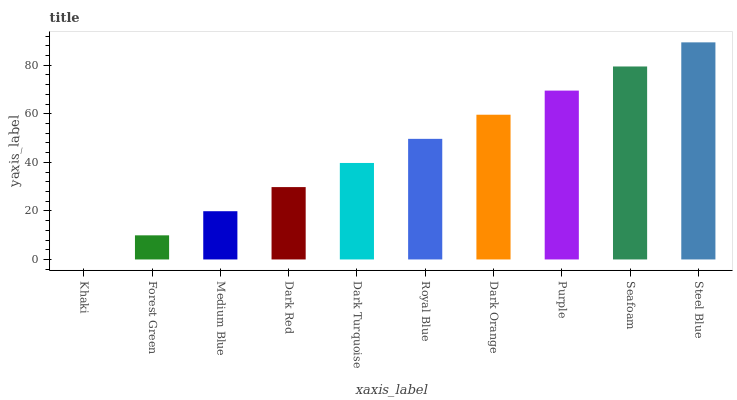Is Khaki the minimum?
Answer yes or no. Yes. Is Steel Blue the maximum?
Answer yes or no. Yes. Is Forest Green the minimum?
Answer yes or no. No. Is Forest Green the maximum?
Answer yes or no. No. Is Forest Green greater than Khaki?
Answer yes or no. Yes. Is Khaki less than Forest Green?
Answer yes or no. Yes. Is Khaki greater than Forest Green?
Answer yes or no. No. Is Forest Green less than Khaki?
Answer yes or no. No. Is Royal Blue the high median?
Answer yes or no. Yes. Is Dark Turquoise the low median?
Answer yes or no. Yes. Is Steel Blue the high median?
Answer yes or no. No. Is Dark Red the low median?
Answer yes or no. No. 